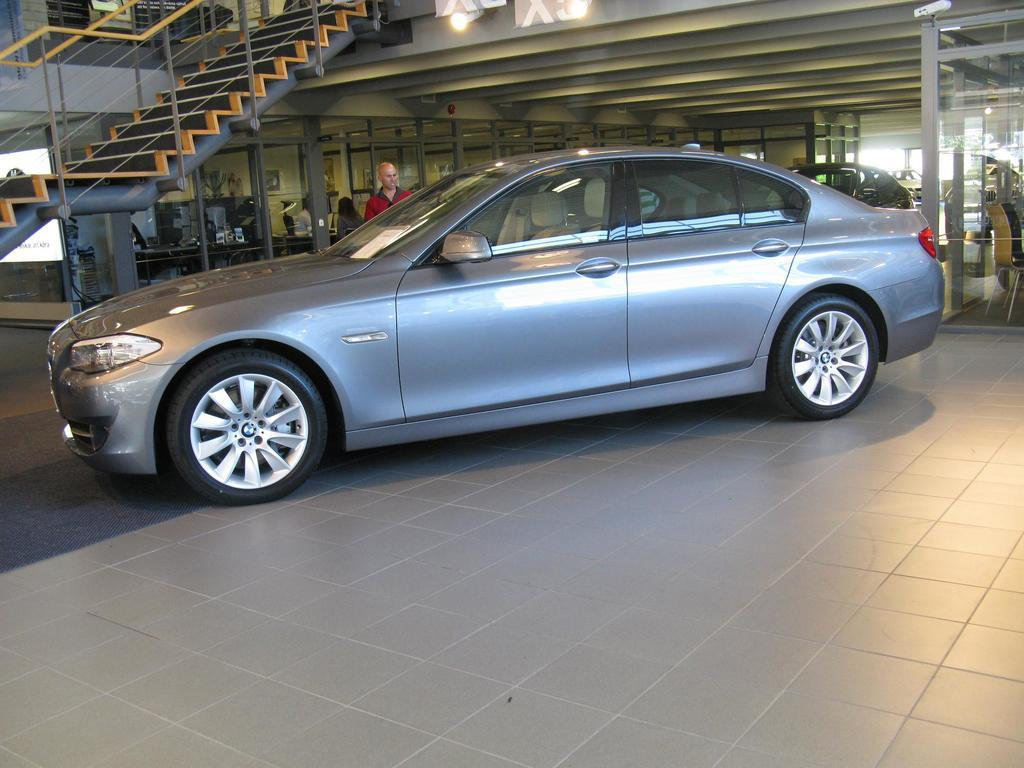What type of structure can be seen in the background of the image? There are compartments with glass doors in the background. What architectural feature is present in the image? There is a staircase in the image. What is the man near in the image? The man is standing near a car. What other objects are visible in the image besides the man and the car? Vehicles are visible in the image. What surface is shown in the image? The image shows a floor. Can you see a peaceful lake in the image? There is no lake present in the image. Is there a board game being played on the floor in the image? There is no board game visible in the image. 